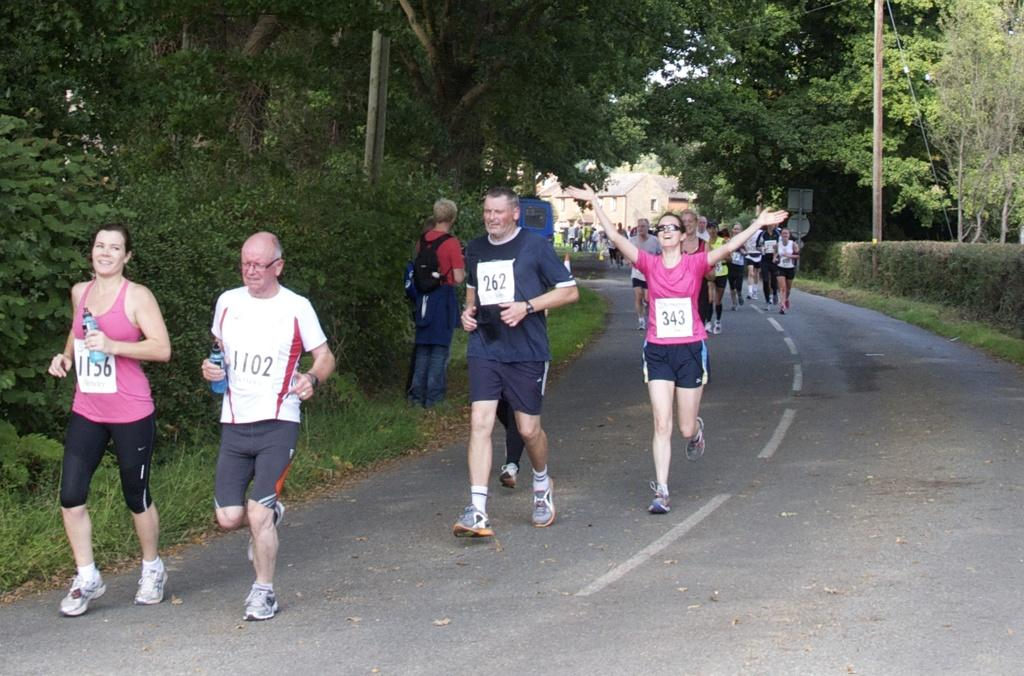What are the people in the image doing? There are people running on the road in the image. Can you describe the person standing in the image? The person standing in the image is holding a bag. What are the two people holding? The two people are holding bottles in the image. What type of vegetation can be seen in the image? There is grass, plants, and trees visible in the image. What can be seen in the background of the image? There are houses and trees in the background of the image. What does the dad say to the person holding the tongue in the image? There is no dad, person holding a tongue, or any dialogue present in the image. 